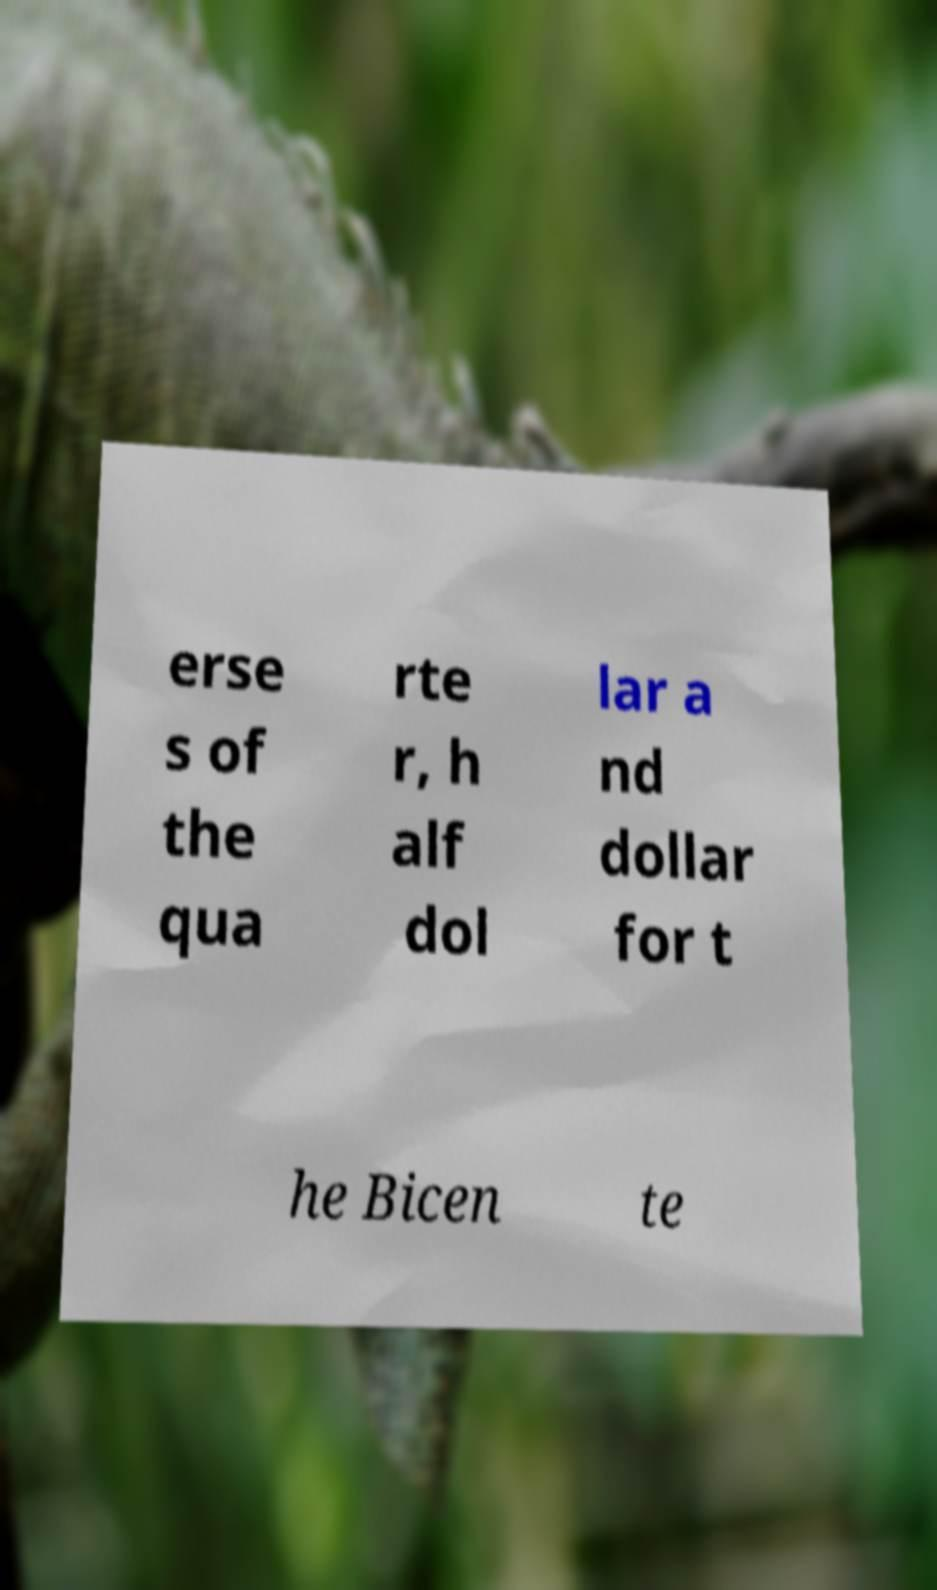Could you assist in decoding the text presented in this image and type it out clearly? erse s of the qua rte r, h alf dol lar a nd dollar for t he Bicen te 